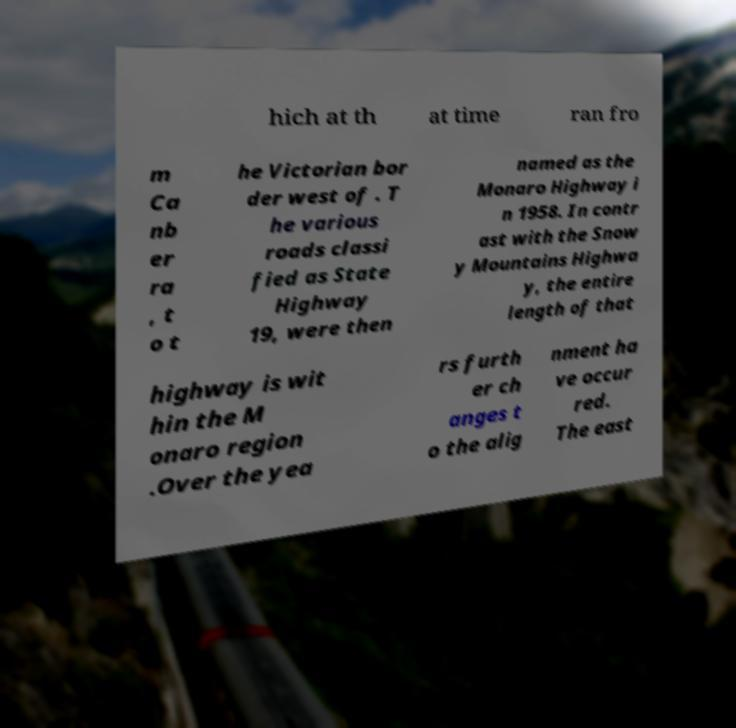Could you assist in decoding the text presented in this image and type it out clearly? hich at th at time ran fro m Ca nb er ra , t o t he Victorian bor der west of . T he various roads classi fied as State Highway 19, were then named as the Monaro Highway i n 1958. In contr ast with the Snow y Mountains Highwa y, the entire length of that highway is wit hin the M onaro region .Over the yea rs furth er ch anges t o the alig nment ha ve occur red. The east 